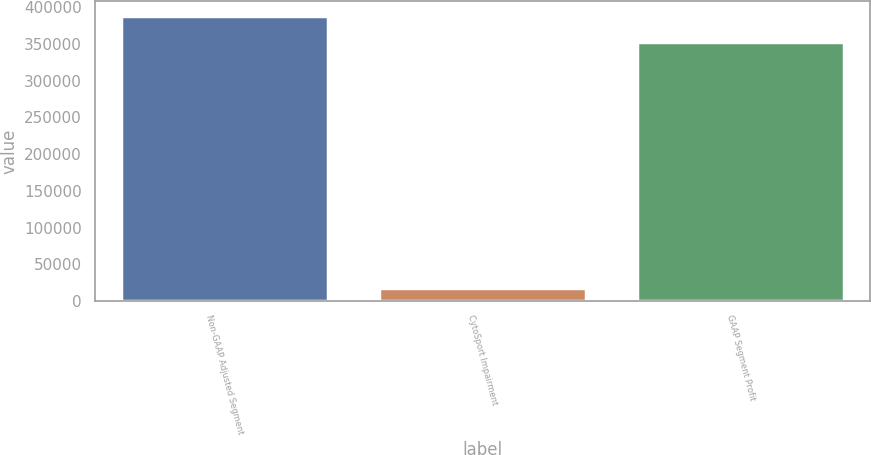Convert chart to OTSL. <chart><loc_0><loc_0><loc_500><loc_500><bar_chart><fcel>Non-GAAP Adjusted Segment<fcel>CytoSport Impairment<fcel>GAAP Segment Profit<nl><fcel>388593<fcel>17279<fcel>353266<nl></chart> 